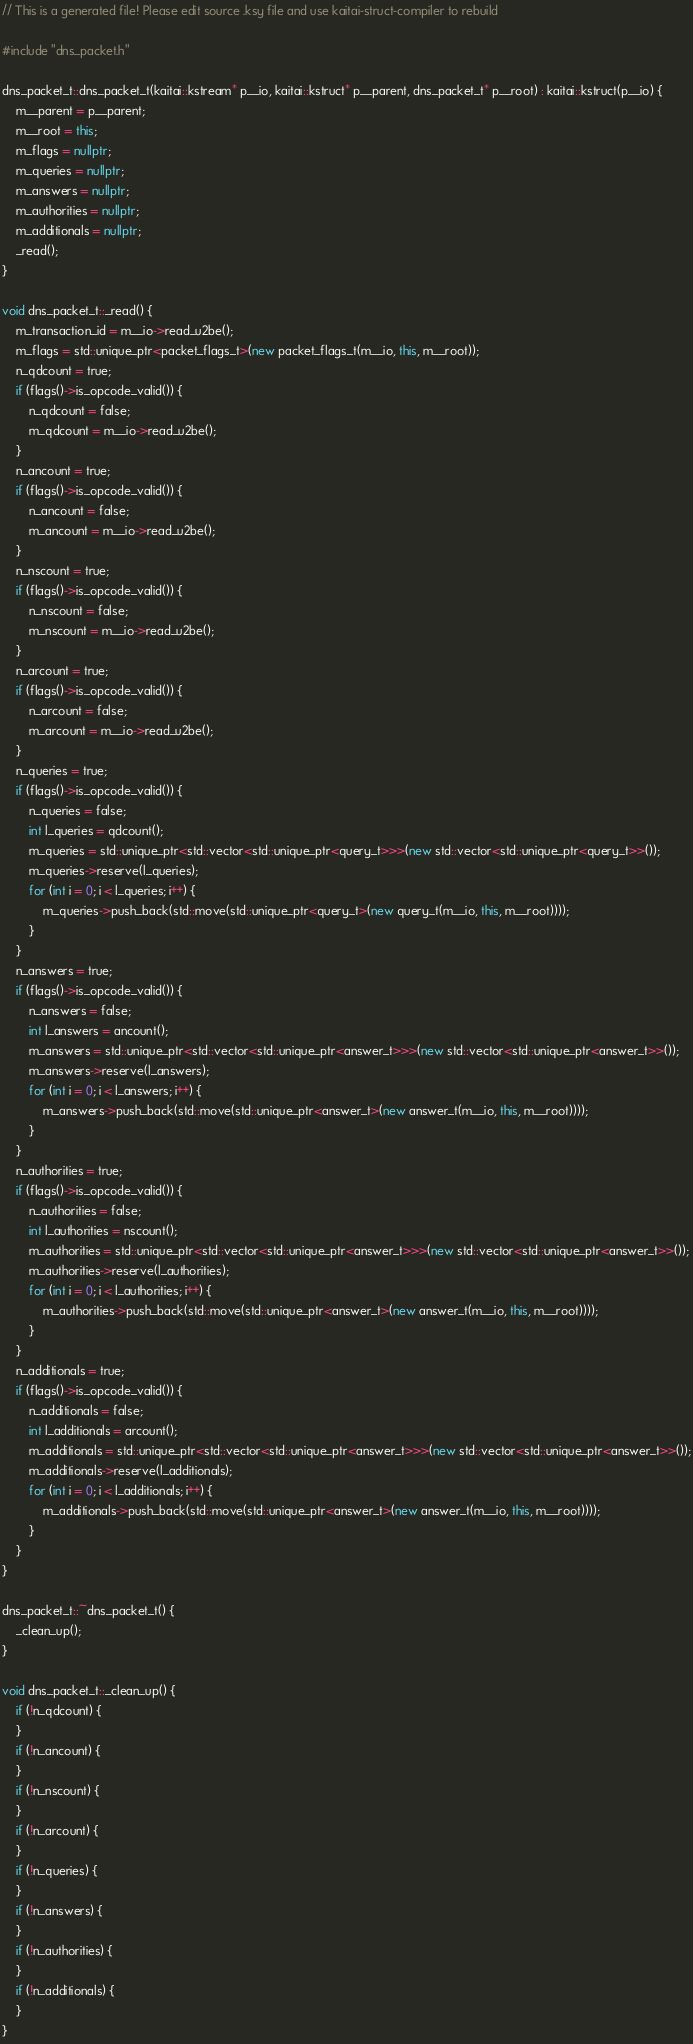<code> <loc_0><loc_0><loc_500><loc_500><_C++_>// This is a generated file! Please edit source .ksy file and use kaitai-struct-compiler to rebuild

#include "dns_packet.h"

dns_packet_t::dns_packet_t(kaitai::kstream* p__io, kaitai::kstruct* p__parent, dns_packet_t* p__root) : kaitai::kstruct(p__io) {
    m__parent = p__parent;
    m__root = this;
    m_flags = nullptr;
    m_queries = nullptr;
    m_answers = nullptr;
    m_authorities = nullptr;
    m_additionals = nullptr;
    _read();
}

void dns_packet_t::_read() {
    m_transaction_id = m__io->read_u2be();
    m_flags = std::unique_ptr<packet_flags_t>(new packet_flags_t(m__io, this, m__root));
    n_qdcount = true;
    if (flags()->is_opcode_valid()) {
        n_qdcount = false;
        m_qdcount = m__io->read_u2be();
    }
    n_ancount = true;
    if (flags()->is_opcode_valid()) {
        n_ancount = false;
        m_ancount = m__io->read_u2be();
    }
    n_nscount = true;
    if (flags()->is_opcode_valid()) {
        n_nscount = false;
        m_nscount = m__io->read_u2be();
    }
    n_arcount = true;
    if (flags()->is_opcode_valid()) {
        n_arcount = false;
        m_arcount = m__io->read_u2be();
    }
    n_queries = true;
    if (flags()->is_opcode_valid()) {
        n_queries = false;
        int l_queries = qdcount();
        m_queries = std::unique_ptr<std::vector<std::unique_ptr<query_t>>>(new std::vector<std::unique_ptr<query_t>>());
        m_queries->reserve(l_queries);
        for (int i = 0; i < l_queries; i++) {
            m_queries->push_back(std::move(std::unique_ptr<query_t>(new query_t(m__io, this, m__root))));
        }
    }
    n_answers = true;
    if (flags()->is_opcode_valid()) {
        n_answers = false;
        int l_answers = ancount();
        m_answers = std::unique_ptr<std::vector<std::unique_ptr<answer_t>>>(new std::vector<std::unique_ptr<answer_t>>());
        m_answers->reserve(l_answers);
        for (int i = 0; i < l_answers; i++) {
            m_answers->push_back(std::move(std::unique_ptr<answer_t>(new answer_t(m__io, this, m__root))));
        }
    }
    n_authorities = true;
    if (flags()->is_opcode_valid()) {
        n_authorities = false;
        int l_authorities = nscount();
        m_authorities = std::unique_ptr<std::vector<std::unique_ptr<answer_t>>>(new std::vector<std::unique_ptr<answer_t>>());
        m_authorities->reserve(l_authorities);
        for (int i = 0; i < l_authorities; i++) {
            m_authorities->push_back(std::move(std::unique_ptr<answer_t>(new answer_t(m__io, this, m__root))));
        }
    }
    n_additionals = true;
    if (flags()->is_opcode_valid()) {
        n_additionals = false;
        int l_additionals = arcount();
        m_additionals = std::unique_ptr<std::vector<std::unique_ptr<answer_t>>>(new std::vector<std::unique_ptr<answer_t>>());
        m_additionals->reserve(l_additionals);
        for (int i = 0; i < l_additionals; i++) {
            m_additionals->push_back(std::move(std::unique_ptr<answer_t>(new answer_t(m__io, this, m__root))));
        }
    }
}

dns_packet_t::~dns_packet_t() {
    _clean_up();
}

void dns_packet_t::_clean_up() {
    if (!n_qdcount) {
    }
    if (!n_ancount) {
    }
    if (!n_nscount) {
    }
    if (!n_arcount) {
    }
    if (!n_queries) {
    }
    if (!n_answers) {
    }
    if (!n_authorities) {
    }
    if (!n_additionals) {
    }
}
</code> 